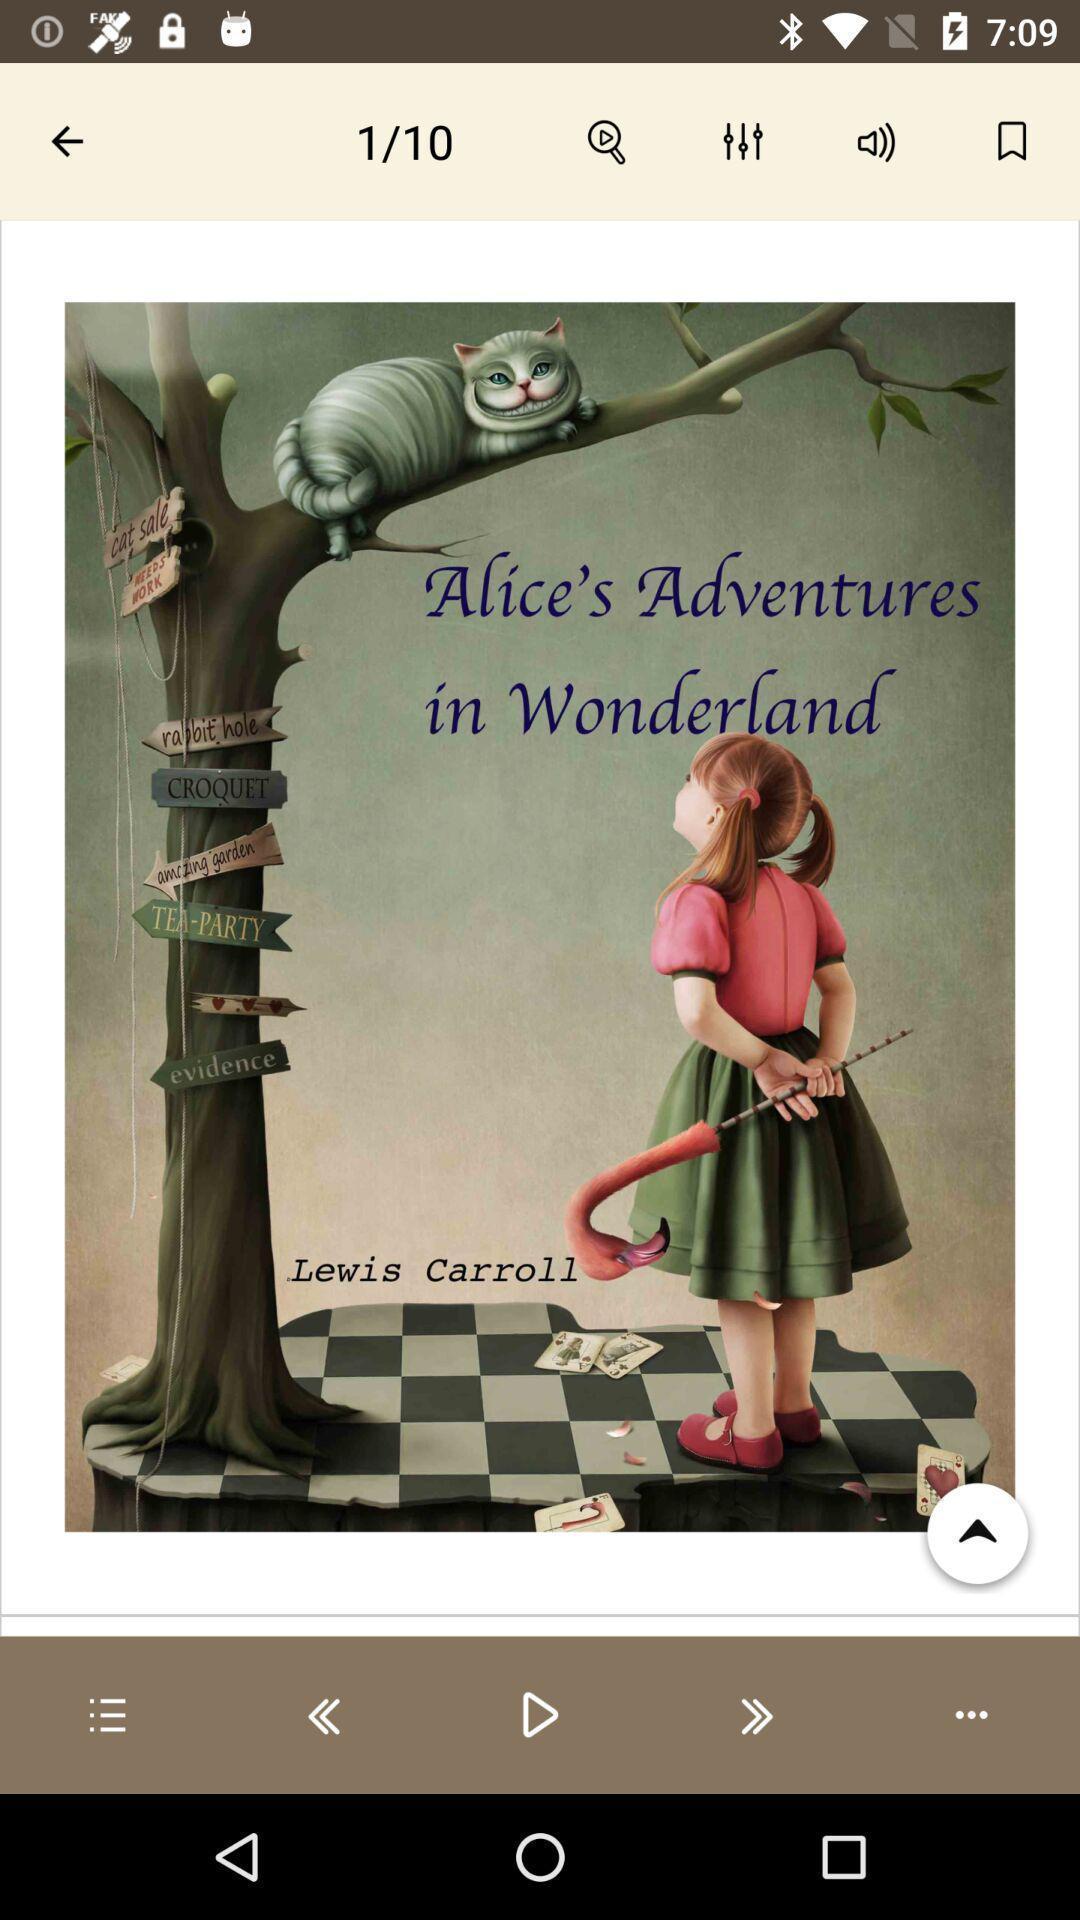Describe this image in words. Page displaying first page of a novel. 